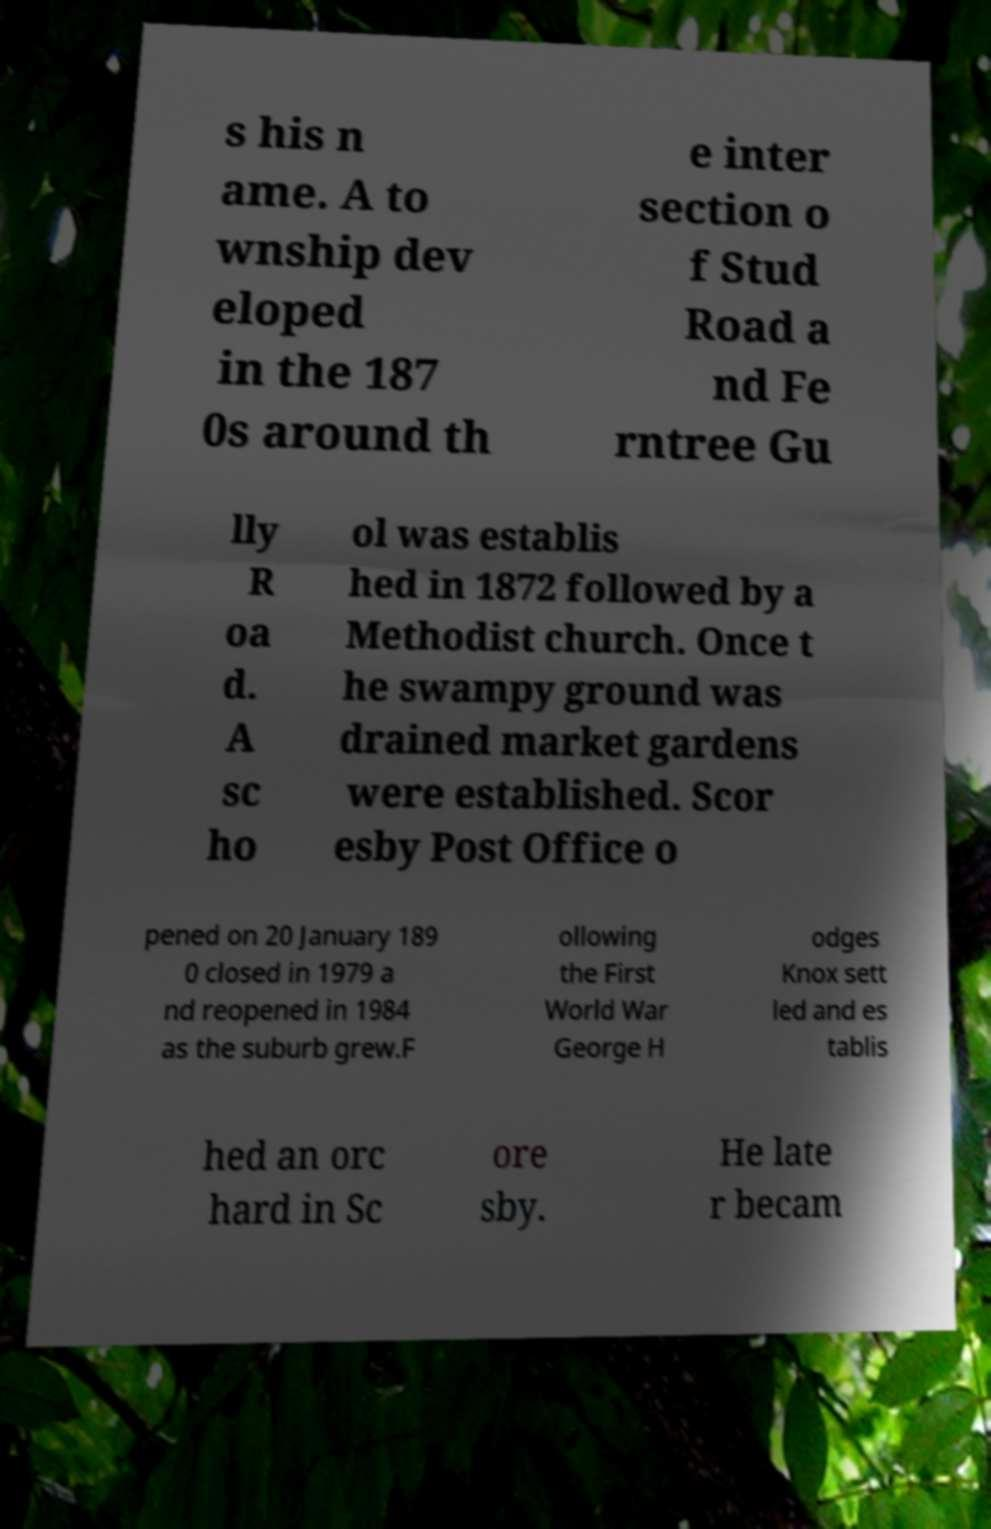Please read and relay the text visible in this image. What does it say? s his n ame. A to wnship dev eloped in the 187 0s around th e inter section o f Stud Road a nd Fe rntree Gu lly R oa d. A sc ho ol was establis hed in 1872 followed by a Methodist church. Once t he swampy ground was drained market gardens were established. Scor esby Post Office o pened on 20 January 189 0 closed in 1979 a nd reopened in 1984 as the suburb grew.F ollowing the First World War George H odges Knox sett led and es tablis hed an orc hard in Sc ore sby. He late r becam 